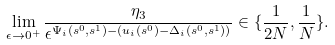<formula> <loc_0><loc_0><loc_500><loc_500>\lim _ { \epsilon \rightarrow 0 ^ { + } } \frac { \eta _ { 3 } } { \epsilon ^ { \Psi _ { i } ( s ^ { 0 } , s ^ { 1 } ) - ( u _ { i } ( s ^ { 0 } ) - \Delta _ { i } ( s ^ { 0 } , s ^ { 1 } ) ) } } \in \{ \frac { 1 } { 2 N } , \frac { 1 } { N } \} .</formula> 